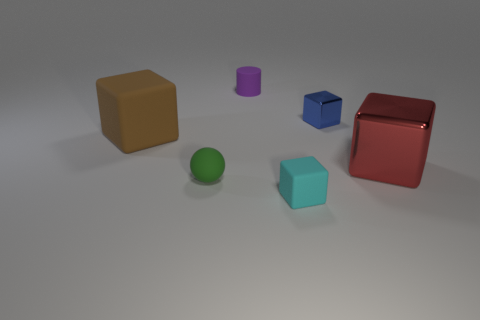Add 2 big gray rubber spheres. How many objects exist? 8 Subtract all cubes. How many objects are left? 2 Add 5 tiny matte cubes. How many tiny matte cubes are left? 6 Add 6 small gray spheres. How many small gray spheres exist? 6 Subtract 0 purple cubes. How many objects are left? 6 Subtract all red cubes. Subtract all cyan rubber objects. How many objects are left? 4 